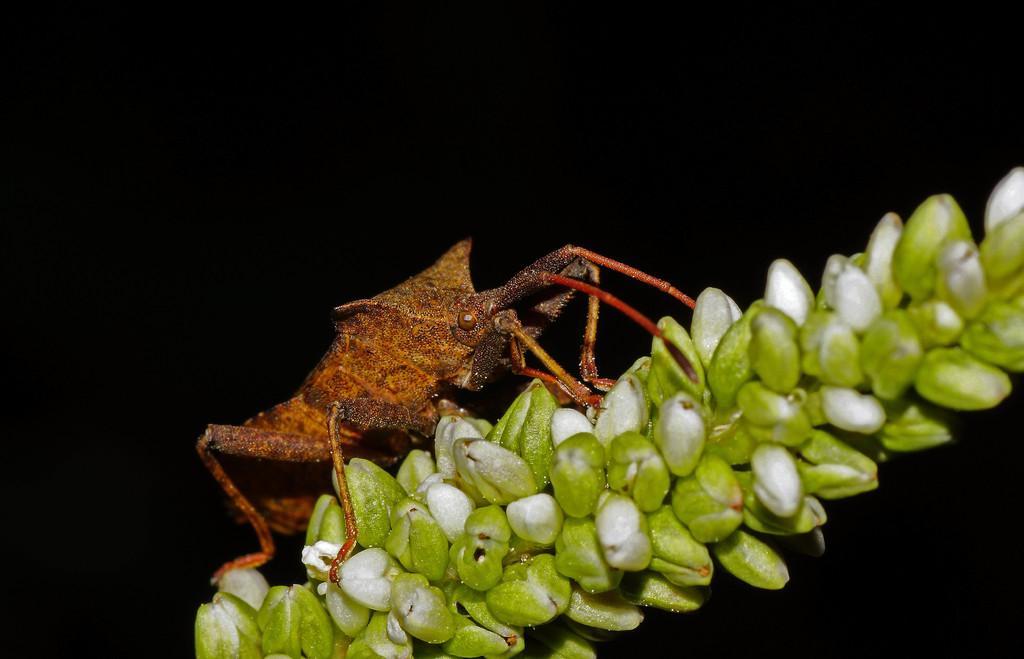Could you give a brief overview of what you see in this image? In this picture I can see an insect in front, which is of brown and red color and it is on the white and green color things. I see that it is dark in the background. 